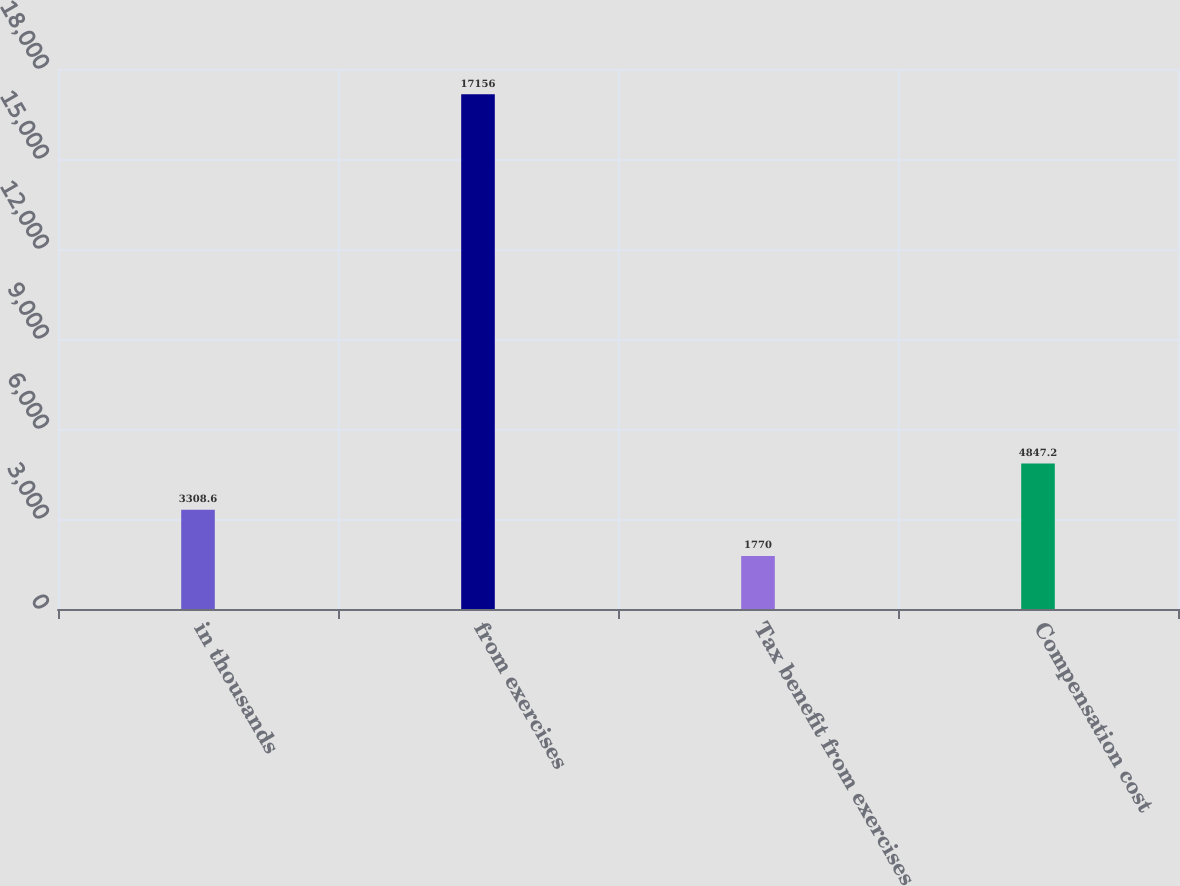Convert chart to OTSL. <chart><loc_0><loc_0><loc_500><loc_500><bar_chart><fcel>in thousands<fcel>from exercises<fcel>Tax benefit from exercises<fcel>Compensation cost<nl><fcel>3308.6<fcel>17156<fcel>1770<fcel>4847.2<nl></chart> 